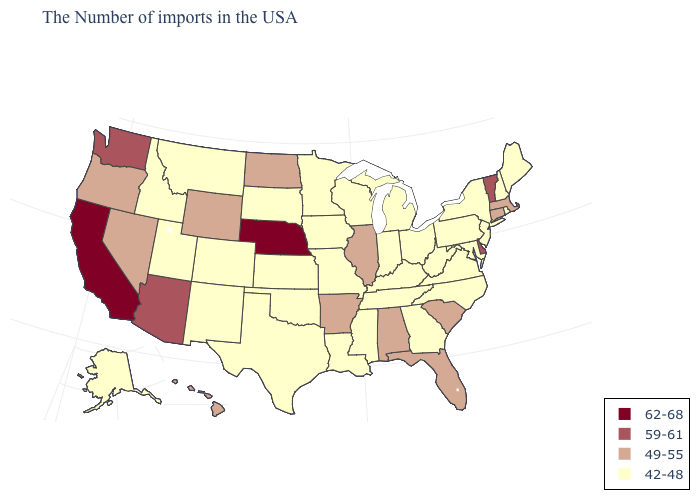Does North Carolina have a lower value than Connecticut?
Write a very short answer. Yes. What is the value of Indiana?
Give a very brief answer. 42-48. Among the states that border Kansas , which have the lowest value?
Quick response, please. Missouri, Oklahoma, Colorado. Name the states that have a value in the range 59-61?
Quick response, please. Vermont, Delaware, Arizona, Washington. What is the highest value in the Northeast ?
Quick response, please. 59-61. What is the lowest value in the MidWest?
Answer briefly. 42-48. Does New Hampshire have a lower value than Wyoming?
Concise answer only. Yes. Which states have the highest value in the USA?
Give a very brief answer. Nebraska, California. Does Hawaii have the highest value in the USA?
Be succinct. No. Among the states that border Kansas , which have the lowest value?
Give a very brief answer. Missouri, Oklahoma, Colorado. Does Oklahoma have the same value as Minnesota?
Be succinct. Yes. Among the states that border Oregon , does California have the highest value?
Concise answer only. Yes. Name the states that have a value in the range 49-55?
Short answer required. Massachusetts, Connecticut, South Carolina, Florida, Alabama, Illinois, Arkansas, North Dakota, Wyoming, Nevada, Oregon, Hawaii. Name the states that have a value in the range 59-61?
Keep it brief. Vermont, Delaware, Arizona, Washington. What is the lowest value in the MidWest?
Answer briefly. 42-48. 